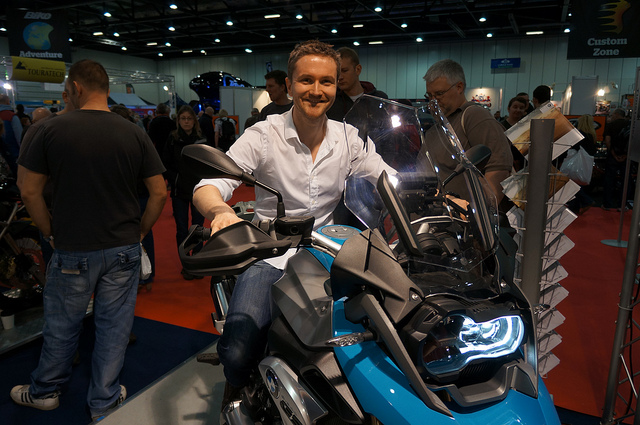Please identify all text content in this image. Adventure Zone Custom 